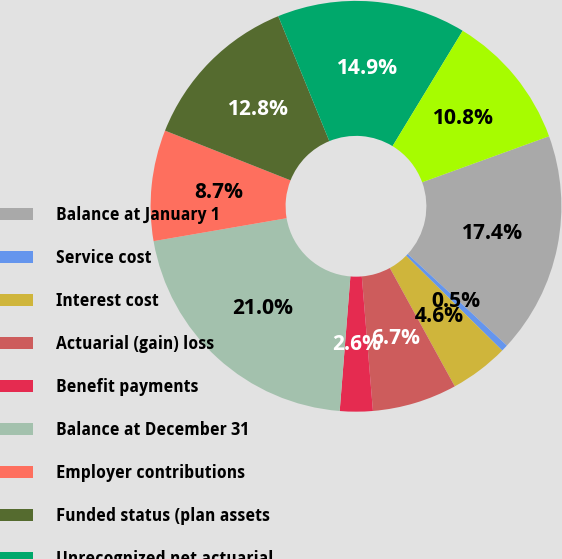Convert chart. <chart><loc_0><loc_0><loc_500><loc_500><pie_chart><fcel>Balance at January 1<fcel>Service cost<fcel>Interest cost<fcel>Actuarial (gain) loss<fcel>Benefit payments<fcel>Balance at December 31<fcel>Employer contributions<fcel>Funded status (plan assets<fcel>Unrecognized net actuarial<fcel>Net amount recognized<nl><fcel>17.4%<fcel>0.53%<fcel>4.62%<fcel>6.67%<fcel>2.58%<fcel>21.02%<fcel>8.72%<fcel>12.82%<fcel>14.87%<fcel>10.77%<nl></chart> 